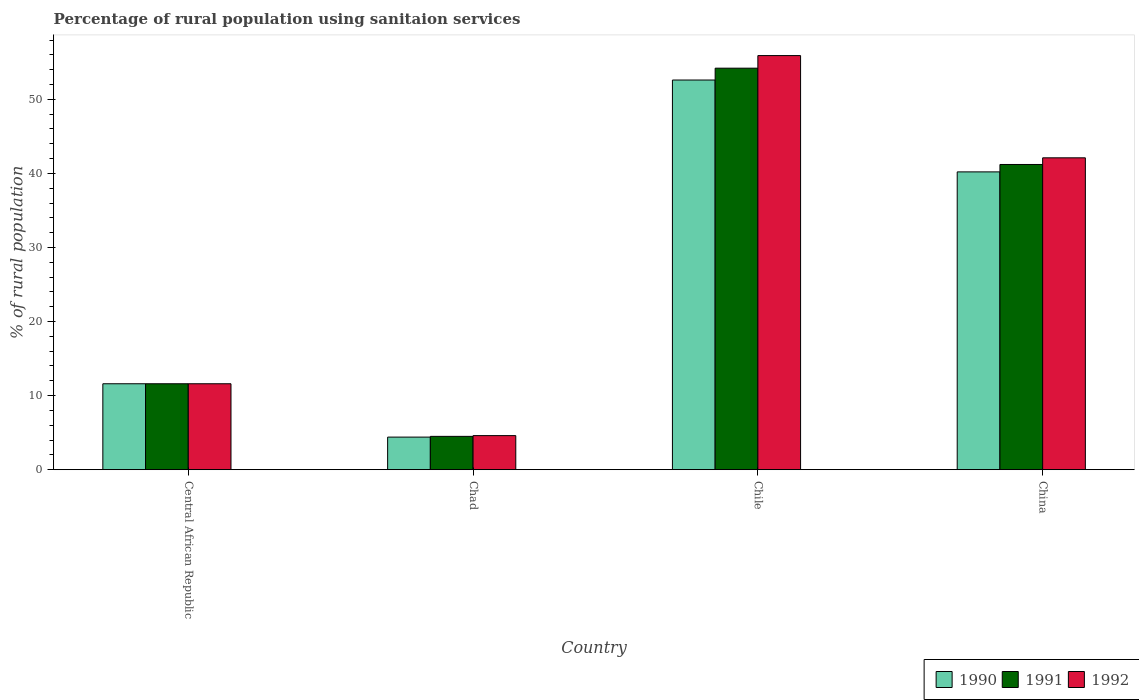How many different coloured bars are there?
Your answer should be compact. 3. Are the number of bars on each tick of the X-axis equal?
Your answer should be very brief. Yes. How many bars are there on the 3rd tick from the right?
Make the answer very short. 3. What is the label of the 1st group of bars from the left?
Make the answer very short. Central African Republic. In how many cases, is the number of bars for a given country not equal to the number of legend labels?
Your answer should be compact. 0. What is the percentage of rural population using sanitaion services in 1992 in China?
Your answer should be very brief. 42.1. Across all countries, what is the maximum percentage of rural population using sanitaion services in 1990?
Ensure brevity in your answer.  52.6. In which country was the percentage of rural population using sanitaion services in 1990 maximum?
Your answer should be very brief. Chile. In which country was the percentage of rural population using sanitaion services in 1990 minimum?
Your response must be concise. Chad. What is the total percentage of rural population using sanitaion services in 1991 in the graph?
Keep it short and to the point. 111.5. What is the difference between the percentage of rural population using sanitaion services in 1991 in Central African Republic and that in China?
Keep it short and to the point. -29.6. What is the difference between the percentage of rural population using sanitaion services in 1992 in Chile and the percentage of rural population using sanitaion services in 1991 in Central African Republic?
Give a very brief answer. 44.3. What is the average percentage of rural population using sanitaion services in 1991 per country?
Provide a succinct answer. 27.88. In how many countries, is the percentage of rural population using sanitaion services in 1991 greater than 52 %?
Make the answer very short. 1. What is the ratio of the percentage of rural population using sanitaion services in 1992 in Chile to that in China?
Your response must be concise. 1.33. Is the percentage of rural population using sanitaion services in 1992 in Chile less than that in China?
Offer a very short reply. No. Is the difference between the percentage of rural population using sanitaion services in 1990 in Central African Republic and Chile greater than the difference between the percentage of rural population using sanitaion services in 1991 in Central African Republic and Chile?
Your response must be concise. Yes. What is the difference between the highest and the second highest percentage of rural population using sanitaion services in 1991?
Your answer should be very brief. 29.6. What is the difference between the highest and the lowest percentage of rural population using sanitaion services in 1990?
Ensure brevity in your answer.  48.2. Is the sum of the percentage of rural population using sanitaion services in 1990 in Central African Republic and China greater than the maximum percentage of rural population using sanitaion services in 1992 across all countries?
Offer a very short reply. No. What does the 1st bar from the right in Chile represents?
Offer a very short reply. 1992. Is it the case that in every country, the sum of the percentage of rural population using sanitaion services in 1992 and percentage of rural population using sanitaion services in 1990 is greater than the percentage of rural population using sanitaion services in 1991?
Provide a short and direct response. Yes. How many countries are there in the graph?
Keep it short and to the point. 4. Are the values on the major ticks of Y-axis written in scientific E-notation?
Provide a short and direct response. No. Does the graph contain grids?
Keep it short and to the point. No. What is the title of the graph?
Keep it short and to the point. Percentage of rural population using sanitaion services. Does "1960" appear as one of the legend labels in the graph?
Make the answer very short. No. What is the label or title of the X-axis?
Give a very brief answer. Country. What is the label or title of the Y-axis?
Provide a short and direct response. % of rural population. What is the % of rural population in 1990 in Central African Republic?
Your response must be concise. 11.6. What is the % of rural population of 1991 in Central African Republic?
Your answer should be very brief. 11.6. What is the % of rural population in 1992 in Central African Republic?
Offer a very short reply. 11.6. What is the % of rural population in 1991 in Chad?
Your answer should be very brief. 4.5. What is the % of rural population of 1992 in Chad?
Offer a very short reply. 4.6. What is the % of rural population of 1990 in Chile?
Ensure brevity in your answer.  52.6. What is the % of rural population of 1991 in Chile?
Your answer should be very brief. 54.2. What is the % of rural population in 1992 in Chile?
Provide a succinct answer. 55.9. What is the % of rural population in 1990 in China?
Give a very brief answer. 40.2. What is the % of rural population in 1991 in China?
Make the answer very short. 41.2. What is the % of rural population in 1992 in China?
Your answer should be compact. 42.1. Across all countries, what is the maximum % of rural population of 1990?
Offer a terse response. 52.6. Across all countries, what is the maximum % of rural population in 1991?
Make the answer very short. 54.2. Across all countries, what is the maximum % of rural population of 1992?
Your answer should be very brief. 55.9. Across all countries, what is the minimum % of rural population of 1990?
Offer a very short reply. 4.4. Across all countries, what is the minimum % of rural population of 1991?
Give a very brief answer. 4.5. Across all countries, what is the minimum % of rural population in 1992?
Make the answer very short. 4.6. What is the total % of rural population in 1990 in the graph?
Offer a very short reply. 108.8. What is the total % of rural population in 1991 in the graph?
Your answer should be compact. 111.5. What is the total % of rural population in 1992 in the graph?
Make the answer very short. 114.2. What is the difference between the % of rural population in 1990 in Central African Republic and that in Chad?
Offer a very short reply. 7.2. What is the difference between the % of rural population of 1992 in Central African Republic and that in Chad?
Make the answer very short. 7. What is the difference between the % of rural population in 1990 in Central African Republic and that in Chile?
Provide a succinct answer. -41. What is the difference between the % of rural population of 1991 in Central African Republic and that in Chile?
Your answer should be compact. -42.6. What is the difference between the % of rural population in 1992 in Central African Republic and that in Chile?
Keep it short and to the point. -44.3. What is the difference between the % of rural population of 1990 in Central African Republic and that in China?
Provide a succinct answer. -28.6. What is the difference between the % of rural population in 1991 in Central African Republic and that in China?
Offer a very short reply. -29.6. What is the difference between the % of rural population in 1992 in Central African Republic and that in China?
Provide a short and direct response. -30.5. What is the difference between the % of rural population in 1990 in Chad and that in Chile?
Ensure brevity in your answer.  -48.2. What is the difference between the % of rural population of 1991 in Chad and that in Chile?
Make the answer very short. -49.7. What is the difference between the % of rural population in 1992 in Chad and that in Chile?
Your response must be concise. -51.3. What is the difference between the % of rural population of 1990 in Chad and that in China?
Provide a short and direct response. -35.8. What is the difference between the % of rural population in 1991 in Chad and that in China?
Give a very brief answer. -36.7. What is the difference between the % of rural population of 1992 in Chad and that in China?
Provide a succinct answer. -37.5. What is the difference between the % of rural population in 1990 in Central African Republic and the % of rural population in 1991 in Chile?
Keep it short and to the point. -42.6. What is the difference between the % of rural population of 1990 in Central African Republic and the % of rural population of 1992 in Chile?
Your answer should be compact. -44.3. What is the difference between the % of rural population of 1991 in Central African Republic and the % of rural population of 1992 in Chile?
Your response must be concise. -44.3. What is the difference between the % of rural population in 1990 in Central African Republic and the % of rural population in 1991 in China?
Give a very brief answer. -29.6. What is the difference between the % of rural population in 1990 in Central African Republic and the % of rural population in 1992 in China?
Your answer should be compact. -30.5. What is the difference between the % of rural population in 1991 in Central African Republic and the % of rural population in 1992 in China?
Ensure brevity in your answer.  -30.5. What is the difference between the % of rural population in 1990 in Chad and the % of rural population in 1991 in Chile?
Your answer should be very brief. -49.8. What is the difference between the % of rural population of 1990 in Chad and the % of rural population of 1992 in Chile?
Provide a short and direct response. -51.5. What is the difference between the % of rural population in 1991 in Chad and the % of rural population in 1992 in Chile?
Your answer should be compact. -51.4. What is the difference between the % of rural population in 1990 in Chad and the % of rural population in 1991 in China?
Provide a short and direct response. -36.8. What is the difference between the % of rural population in 1990 in Chad and the % of rural population in 1992 in China?
Give a very brief answer. -37.7. What is the difference between the % of rural population in 1991 in Chad and the % of rural population in 1992 in China?
Give a very brief answer. -37.6. What is the average % of rural population in 1990 per country?
Your response must be concise. 27.2. What is the average % of rural population in 1991 per country?
Provide a succinct answer. 27.88. What is the average % of rural population in 1992 per country?
Provide a short and direct response. 28.55. What is the difference between the % of rural population in 1990 and % of rural population in 1992 in Central African Republic?
Your answer should be very brief. 0. What is the difference between the % of rural population in 1991 and % of rural population in 1992 in Central African Republic?
Provide a short and direct response. 0. What is the difference between the % of rural population of 1990 and % of rural population of 1992 in Chad?
Ensure brevity in your answer.  -0.2. What is the difference between the % of rural population of 1990 and % of rural population of 1992 in China?
Give a very brief answer. -1.9. What is the difference between the % of rural population in 1991 and % of rural population in 1992 in China?
Provide a succinct answer. -0.9. What is the ratio of the % of rural population in 1990 in Central African Republic to that in Chad?
Your answer should be compact. 2.64. What is the ratio of the % of rural population in 1991 in Central African Republic to that in Chad?
Offer a terse response. 2.58. What is the ratio of the % of rural population of 1992 in Central African Republic to that in Chad?
Make the answer very short. 2.52. What is the ratio of the % of rural population of 1990 in Central African Republic to that in Chile?
Your answer should be very brief. 0.22. What is the ratio of the % of rural population of 1991 in Central African Republic to that in Chile?
Offer a very short reply. 0.21. What is the ratio of the % of rural population of 1992 in Central African Republic to that in Chile?
Ensure brevity in your answer.  0.21. What is the ratio of the % of rural population of 1990 in Central African Republic to that in China?
Your answer should be very brief. 0.29. What is the ratio of the % of rural population of 1991 in Central African Republic to that in China?
Your answer should be compact. 0.28. What is the ratio of the % of rural population in 1992 in Central African Republic to that in China?
Your response must be concise. 0.28. What is the ratio of the % of rural population in 1990 in Chad to that in Chile?
Provide a short and direct response. 0.08. What is the ratio of the % of rural population of 1991 in Chad to that in Chile?
Make the answer very short. 0.08. What is the ratio of the % of rural population in 1992 in Chad to that in Chile?
Offer a terse response. 0.08. What is the ratio of the % of rural population of 1990 in Chad to that in China?
Offer a terse response. 0.11. What is the ratio of the % of rural population in 1991 in Chad to that in China?
Offer a terse response. 0.11. What is the ratio of the % of rural population of 1992 in Chad to that in China?
Offer a terse response. 0.11. What is the ratio of the % of rural population in 1990 in Chile to that in China?
Ensure brevity in your answer.  1.31. What is the ratio of the % of rural population of 1991 in Chile to that in China?
Your answer should be compact. 1.32. What is the ratio of the % of rural population of 1992 in Chile to that in China?
Your response must be concise. 1.33. What is the difference between the highest and the second highest % of rural population in 1990?
Ensure brevity in your answer.  12.4. What is the difference between the highest and the lowest % of rural population of 1990?
Make the answer very short. 48.2. What is the difference between the highest and the lowest % of rural population of 1991?
Make the answer very short. 49.7. What is the difference between the highest and the lowest % of rural population in 1992?
Make the answer very short. 51.3. 